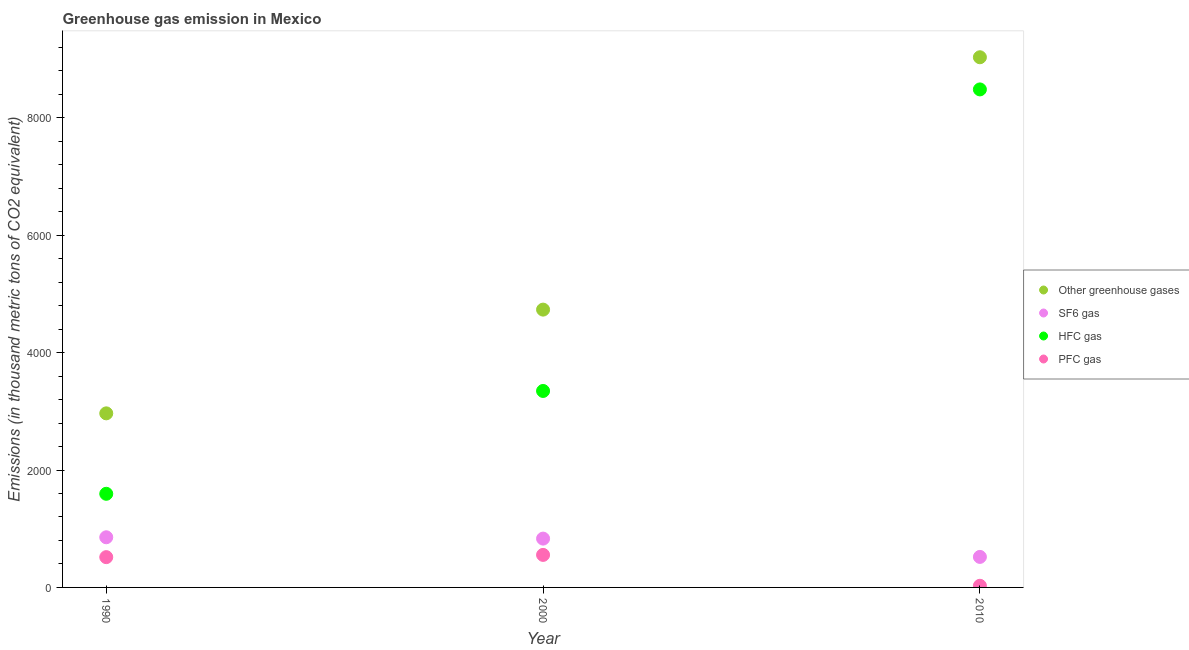How many different coloured dotlines are there?
Your answer should be very brief. 4. What is the emission of sf6 gas in 1990?
Make the answer very short. 854.5. Across all years, what is the maximum emission of greenhouse gases?
Offer a terse response. 9033. Across all years, what is the minimum emission of greenhouse gases?
Your answer should be compact. 2965.8. In which year was the emission of sf6 gas minimum?
Provide a short and direct response. 2010. What is the total emission of pfc gas in the graph?
Your answer should be very brief. 1098.1. What is the difference between the emission of sf6 gas in 1990 and that in 2010?
Provide a succinct answer. 334.5. What is the difference between the emission of pfc gas in 2010 and the emission of greenhouse gases in 2000?
Provide a short and direct response. -4705.2. What is the average emission of pfc gas per year?
Give a very brief answer. 366.03. In the year 1990, what is the difference between the emission of greenhouse gases and emission of pfc gas?
Offer a very short reply. 2449.8. What is the ratio of the emission of pfc gas in 1990 to that in 2010?
Make the answer very short. 18.43. Is the emission of hfc gas in 1990 less than that in 2010?
Your response must be concise. Yes. What is the difference between the highest and the second highest emission of sf6 gas?
Keep it short and to the point. 22.7. What is the difference between the highest and the lowest emission of hfc gas?
Your response must be concise. 6889.7. Is it the case that in every year, the sum of the emission of pfc gas and emission of hfc gas is greater than the sum of emission of sf6 gas and emission of greenhouse gases?
Your answer should be compact. No. How many dotlines are there?
Your response must be concise. 4. What is the difference between two consecutive major ticks on the Y-axis?
Keep it short and to the point. 2000. Are the values on the major ticks of Y-axis written in scientific E-notation?
Your response must be concise. No. Does the graph contain grids?
Give a very brief answer. No. What is the title of the graph?
Provide a succinct answer. Greenhouse gas emission in Mexico. What is the label or title of the X-axis?
Provide a short and direct response. Year. What is the label or title of the Y-axis?
Your answer should be very brief. Emissions (in thousand metric tons of CO2 equivalent). What is the Emissions (in thousand metric tons of CO2 equivalent) of Other greenhouse gases in 1990?
Ensure brevity in your answer.  2965.8. What is the Emissions (in thousand metric tons of CO2 equivalent) in SF6 gas in 1990?
Make the answer very short. 854.5. What is the Emissions (in thousand metric tons of CO2 equivalent) of HFC gas in 1990?
Provide a succinct answer. 1595.3. What is the Emissions (in thousand metric tons of CO2 equivalent) of PFC gas in 1990?
Offer a terse response. 516. What is the Emissions (in thousand metric tons of CO2 equivalent) of Other greenhouse gases in 2000?
Make the answer very short. 4733.2. What is the Emissions (in thousand metric tons of CO2 equivalent) in SF6 gas in 2000?
Give a very brief answer. 831.8. What is the Emissions (in thousand metric tons of CO2 equivalent) in HFC gas in 2000?
Give a very brief answer. 3347.3. What is the Emissions (in thousand metric tons of CO2 equivalent) of PFC gas in 2000?
Your answer should be compact. 554.1. What is the Emissions (in thousand metric tons of CO2 equivalent) of Other greenhouse gases in 2010?
Give a very brief answer. 9033. What is the Emissions (in thousand metric tons of CO2 equivalent) of SF6 gas in 2010?
Ensure brevity in your answer.  520. What is the Emissions (in thousand metric tons of CO2 equivalent) in HFC gas in 2010?
Offer a terse response. 8485. What is the Emissions (in thousand metric tons of CO2 equivalent) of PFC gas in 2010?
Provide a short and direct response. 28. Across all years, what is the maximum Emissions (in thousand metric tons of CO2 equivalent) in Other greenhouse gases?
Your answer should be compact. 9033. Across all years, what is the maximum Emissions (in thousand metric tons of CO2 equivalent) in SF6 gas?
Provide a short and direct response. 854.5. Across all years, what is the maximum Emissions (in thousand metric tons of CO2 equivalent) in HFC gas?
Provide a short and direct response. 8485. Across all years, what is the maximum Emissions (in thousand metric tons of CO2 equivalent) in PFC gas?
Your answer should be very brief. 554.1. Across all years, what is the minimum Emissions (in thousand metric tons of CO2 equivalent) of Other greenhouse gases?
Keep it short and to the point. 2965.8. Across all years, what is the minimum Emissions (in thousand metric tons of CO2 equivalent) of SF6 gas?
Offer a very short reply. 520. Across all years, what is the minimum Emissions (in thousand metric tons of CO2 equivalent) of HFC gas?
Your answer should be very brief. 1595.3. Across all years, what is the minimum Emissions (in thousand metric tons of CO2 equivalent) in PFC gas?
Keep it short and to the point. 28. What is the total Emissions (in thousand metric tons of CO2 equivalent) in Other greenhouse gases in the graph?
Ensure brevity in your answer.  1.67e+04. What is the total Emissions (in thousand metric tons of CO2 equivalent) in SF6 gas in the graph?
Provide a succinct answer. 2206.3. What is the total Emissions (in thousand metric tons of CO2 equivalent) of HFC gas in the graph?
Your answer should be very brief. 1.34e+04. What is the total Emissions (in thousand metric tons of CO2 equivalent) in PFC gas in the graph?
Offer a terse response. 1098.1. What is the difference between the Emissions (in thousand metric tons of CO2 equivalent) of Other greenhouse gases in 1990 and that in 2000?
Your answer should be very brief. -1767.4. What is the difference between the Emissions (in thousand metric tons of CO2 equivalent) of SF6 gas in 1990 and that in 2000?
Your response must be concise. 22.7. What is the difference between the Emissions (in thousand metric tons of CO2 equivalent) of HFC gas in 1990 and that in 2000?
Offer a terse response. -1752. What is the difference between the Emissions (in thousand metric tons of CO2 equivalent) of PFC gas in 1990 and that in 2000?
Your answer should be compact. -38.1. What is the difference between the Emissions (in thousand metric tons of CO2 equivalent) of Other greenhouse gases in 1990 and that in 2010?
Ensure brevity in your answer.  -6067.2. What is the difference between the Emissions (in thousand metric tons of CO2 equivalent) in SF6 gas in 1990 and that in 2010?
Provide a short and direct response. 334.5. What is the difference between the Emissions (in thousand metric tons of CO2 equivalent) in HFC gas in 1990 and that in 2010?
Provide a short and direct response. -6889.7. What is the difference between the Emissions (in thousand metric tons of CO2 equivalent) in PFC gas in 1990 and that in 2010?
Make the answer very short. 488. What is the difference between the Emissions (in thousand metric tons of CO2 equivalent) of Other greenhouse gases in 2000 and that in 2010?
Make the answer very short. -4299.8. What is the difference between the Emissions (in thousand metric tons of CO2 equivalent) of SF6 gas in 2000 and that in 2010?
Your answer should be compact. 311.8. What is the difference between the Emissions (in thousand metric tons of CO2 equivalent) of HFC gas in 2000 and that in 2010?
Your response must be concise. -5137.7. What is the difference between the Emissions (in thousand metric tons of CO2 equivalent) in PFC gas in 2000 and that in 2010?
Ensure brevity in your answer.  526.1. What is the difference between the Emissions (in thousand metric tons of CO2 equivalent) in Other greenhouse gases in 1990 and the Emissions (in thousand metric tons of CO2 equivalent) in SF6 gas in 2000?
Offer a very short reply. 2134. What is the difference between the Emissions (in thousand metric tons of CO2 equivalent) of Other greenhouse gases in 1990 and the Emissions (in thousand metric tons of CO2 equivalent) of HFC gas in 2000?
Make the answer very short. -381.5. What is the difference between the Emissions (in thousand metric tons of CO2 equivalent) in Other greenhouse gases in 1990 and the Emissions (in thousand metric tons of CO2 equivalent) in PFC gas in 2000?
Ensure brevity in your answer.  2411.7. What is the difference between the Emissions (in thousand metric tons of CO2 equivalent) of SF6 gas in 1990 and the Emissions (in thousand metric tons of CO2 equivalent) of HFC gas in 2000?
Your answer should be very brief. -2492.8. What is the difference between the Emissions (in thousand metric tons of CO2 equivalent) of SF6 gas in 1990 and the Emissions (in thousand metric tons of CO2 equivalent) of PFC gas in 2000?
Keep it short and to the point. 300.4. What is the difference between the Emissions (in thousand metric tons of CO2 equivalent) in HFC gas in 1990 and the Emissions (in thousand metric tons of CO2 equivalent) in PFC gas in 2000?
Keep it short and to the point. 1041.2. What is the difference between the Emissions (in thousand metric tons of CO2 equivalent) of Other greenhouse gases in 1990 and the Emissions (in thousand metric tons of CO2 equivalent) of SF6 gas in 2010?
Provide a succinct answer. 2445.8. What is the difference between the Emissions (in thousand metric tons of CO2 equivalent) in Other greenhouse gases in 1990 and the Emissions (in thousand metric tons of CO2 equivalent) in HFC gas in 2010?
Give a very brief answer. -5519.2. What is the difference between the Emissions (in thousand metric tons of CO2 equivalent) in Other greenhouse gases in 1990 and the Emissions (in thousand metric tons of CO2 equivalent) in PFC gas in 2010?
Your answer should be very brief. 2937.8. What is the difference between the Emissions (in thousand metric tons of CO2 equivalent) of SF6 gas in 1990 and the Emissions (in thousand metric tons of CO2 equivalent) of HFC gas in 2010?
Offer a very short reply. -7630.5. What is the difference between the Emissions (in thousand metric tons of CO2 equivalent) in SF6 gas in 1990 and the Emissions (in thousand metric tons of CO2 equivalent) in PFC gas in 2010?
Your response must be concise. 826.5. What is the difference between the Emissions (in thousand metric tons of CO2 equivalent) of HFC gas in 1990 and the Emissions (in thousand metric tons of CO2 equivalent) of PFC gas in 2010?
Offer a very short reply. 1567.3. What is the difference between the Emissions (in thousand metric tons of CO2 equivalent) of Other greenhouse gases in 2000 and the Emissions (in thousand metric tons of CO2 equivalent) of SF6 gas in 2010?
Your answer should be compact. 4213.2. What is the difference between the Emissions (in thousand metric tons of CO2 equivalent) of Other greenhouse gases in 2000 and the Emissions (in thousand metric tons of CO2 equivalent) of HFC gas in 2010?
Offer a very short reply. -3751.8. What is the difference between the Emissions (in thousand metric tons of CO2 equivalent) of Other greenhouse gases in 2000 and the Emissions (in thousand metric tons of CO2 equivalent) of PFC gas in 2010?
Provide a succinct answer. 4705.2. What is the difference between the Emissions (in thousand metric tons of CO2 equivalent) in SF6 gas in 2000 and the Emissions (in thousand metric tons of CO2 equivalent) in HFC gas in 2010?
Give a very brief answer. -7653.2. What is the difference between the Emissions (in thousand metric tons of CO2 equivalent) of SF6 gas in 2000 and the Emissions (in thousand metric tons of CO2 equivalent) of PFC gas in 2010?
Ensure brevity in your answer.  803.8. What is the difference between the Emissions (in thousand metric tons of CO2 equivalent) in HFC gas in 2000 and the Emissions (in thousand metric tons of CO2 equivalent) in PFC gas in 2010?
Keep it short and to the point. 3319.3. What is the average Emissions (in thousand metric tons of CO2 equivalent) of Other greenhouse gases per year?
Offer a terse response. 5577.33. What is the average Emissions (in thousand metric tons of CO2 equivalent) in SF6 gas per year?
Make the answer very short. 735.43. What is the average Emissions (in thousand metric tons of CO2 equivalent) in HFC gas per year?
Keep it short and to the point. 4475.87. What is the average Emissions (in thousand metric tons of CO2 equivalent) in PFC gas per year?
Provide a short and direct response. 366.03. In the year 1990, what is the difference between the Emissions (in thousand metric tons of CO2 equivalent) of Other greenhouse gases and Emissions (in thousand metric tons of CO2 equivalent) of SF6 gas?
Give a very brief answer. 2111.3. In the year 1990, what is the difference between the Emissions (in thousand metric tons of CO2 equivalent) of Other greenhouse gases and Emissions (in thousand metric tons of CO2 equivalent) of HFC gas?
Provide a short and direct response. 1370.5. In the year 1990, what is the difference between the Emissions (in thousand metric tons of CO2 equivalent) in Other greenhouse gases and Emissions (in thousand metric tons of CO2 equivalent) in PFC gas?
Offer a very short reply. 2449.8. In the year 1990, what is the difference between the Emissions (in thousand metric tons of CO2 equivalent) in SF6 gas and Emissions (in thousand metric tons of CO2 equivalent) in HFC gas?
Your answer should be very brief. -740.8. In the year 1990, what is the difference between the Emissions (in thousand metric tons of CO2 equivalent) of SF6 gas and Emissions (in thousand metric tons of CO2 equivalent) of PFC gas?
Offer a terse response. 338.5. In the year 1990, what is the difference between the Emissions (in thousand metric tons of CO2 equivalent) of HFC gas and Emissions (in thousand metric tons of CO2 equivalent) of PFC gas?
Provide a short and direct response. 1079.3. In the year 2000, what is the difference between the Emissions (in thousand metric tons of CO2 equivalent) in Other greenhouse gases and Emissions (in thousand metric tons of CO2 equivalent) in SF6 gas?
Offer a terse response. 3901.4. In the year 2000, what is the difference between the Emissions (in thousand metric tons of CO2 equivalent) in Other greenhouse gases and Emissions (in thousand metric tons of CO2 equivalent) in HFC gas?
Your answer should be compact. 1385.9. In the year 2000, what is the difference between the Emissions (in thousand metric tons of CO2 equivalent) in Other greenhouse gases and Emissions (in thousand metric tons of CO2 equivalent) in PFC gas?
Make the answer very short. 4179.1. In the year 2000, what is the difference between the Emissions (in thousand metric tons of CO2 equivalent) in SF6 gas and Emissions (in thousand metric tons of CO2 equivalent) in HFC gas?
Give a very brief answer. -2515.5. In the year 2000, what is the difference between the Emissions (in thousand metric tons of CO2 equivalent) in SF6 gas and Emissions (in thousand metric tons of CO2 equivalent) in PFC gas?
Offer a terse response. 277.7. In the year 2000, what is the difference between the Emissions (in thousand metric tons of CO2 equivalent) in HFC gas and Emissions (in thousand metric tons of CO2 equivalent) in PFC gas?
Your answer should be very brief. 2793.2. In the year 2010, what is the difference between the Emissions (in thousand metric tons of CO2 equivalent) in Other greenhouse gases and Emissions (in thousand metric tons of CO2 equivalent) in SF6 gas?
Make the answer very short. 8513. In the year 2010, what is the difference between the Emissions (in thousand metric tons of CO2 equivalent) of Other greenhouse gases and Emissions (in thousand metric tons of CO2 equivalent) of HFC gas?
Make the answer very short. 548. In the year 2010, what is the difference between the Emissions (in thousand metric tons of CO2 equivalent) in Other greenhouse gases and Emissions (in thousand metric tons of CO2 equivalent) in PFC gas?
Provide a short and direct response. 9005. In the year 2010, what is the difference between the Emissions (in thousand metric tons of CO2 equivalent) in SF6 gas and Emissions (in thousand metric tons of CO2 equivalent) in HFC gas?
Offer a terse response. -7965. In the year 2010, what is the difference between the Emissions (in thousand metric tons of CO2 equivalent) in SF6 gas and Emissions (in thousand metric tons of CO2 equivalent) in PFC gas?
Offer a terse response. 492. In the year 2010, what is the difference between the Emissions (in thousand metric tons of CO2 equivalent) in HFC gas and Emissions (in thousand metric tons of CO2 equivalent) in PFC gas?
Make the answer very short. 8457. What is the ratio of the Emissions (in thousand metric tons of CO2 equivalent) of Other greenhouse gases in 1990 to that in 2000?
Ensure brevity in your answer.  0.63. What is the ratio of the Emissions (in thousand metric tons of CO2 equivalent) of SF6 gas in 1990 to that in 2000?
Ensure brevity in your answer.  1.03. What is the ratio of the Emissions (in thousand metric tons of CO2 equivalent) of HFC gas in 1990 to that in 2000?
Your answer should be compact. 0.48. What is the ratio of the Emissions (in thousand metric tons of CO2 equivalent) of PFC gas in 1990 to that in 2000?
Keep it short and to the point. 0.93. What is the ratio of the Emissions (in thousand metric tons of CO2 equivalent) in Other greenhouse gases in 1990 to that in 2010?
Offer a terse response. 0.33. What is the ratio of the Emissions (in thousand metric tons of CO2 equivalent) in SF6 gas in 1990 to that in 2010?
Offer a terse response. 1.64. What is the ratio of the Emissions (in thousand metric tons of CO2 equivalent) in HFC gas in 1990 to that in 2010?
Your answer should be very brief. 0.19. What is the ratio of the Emissions (in thousand metric tons of CO2 equivalent) of PFC gas in 1990 to that in 2010?
Your answer should be compact. 18.43. What is the ratio of the Emissions (in thousand metric tons of CO2 equivalent) in Other greenhouse gases in 2000 to that in 2010?
Provide a succinct answer. 0.52. What is the ratio of the Emissions (in thousand metric tons of CO2 equivalent) of SF6 gas in 2000 to that in 2010?
Your response must be concise. 1.6. What is the ratio of the Emissions (in thousand metric tons of CO2 equivalent) in HFC gas in 2000 to that in 2010?
Make the answer very short. 0.39. What is the ratio of the Emissions (in thousand metric tons of CO2 equivalent) of PFC gas in 2000 to that in 2010?
Offer a very short reply. 19.79. What is the difference between the highest and the second highest Emissions (in thousand metric tons of CO2 equivalent) in Other greenhouse gases?
Keep it short and to the point. 4299.8. What is the difference between the highest and the second highest Emissions (in thousand metric tons of CO2 equivalent) in SF6 gas?
Offer a very short reply. 22.7. What is the difference between the highest and the second highest Emissions (in thousand metric tons of CO2 equivalent) of HFC gas?
Your answer should be very brief. 5137.7. What is the difference between the highest and the second highest Emissions (in thousand metric tons of CO2 equivalent) of PFC gas?
Your answer should be compact. 38.1. What is the difference between the highest and the lowest Emissions (in thousand metric tons of CO2 equivalent) of Other greenhouse gases?
Your response must be concise. 6067.2. What is the difference between the highest and the lowest Emissions (in thousand metric tons of CO2 equivalent) of SF6 gas?
Offer a very short reply. 334.5. What is the difference between the highest and the lowest Emissions (in thousand metric tons of CO2 equivalent) of HFC gas?
Your answer should be compact. 6889.7. What is the difference between the highest and the lowest Emissions (in thousand metric tons of CO2 equivalent) in PFC gas?
Offer a terse response. 526.1. 